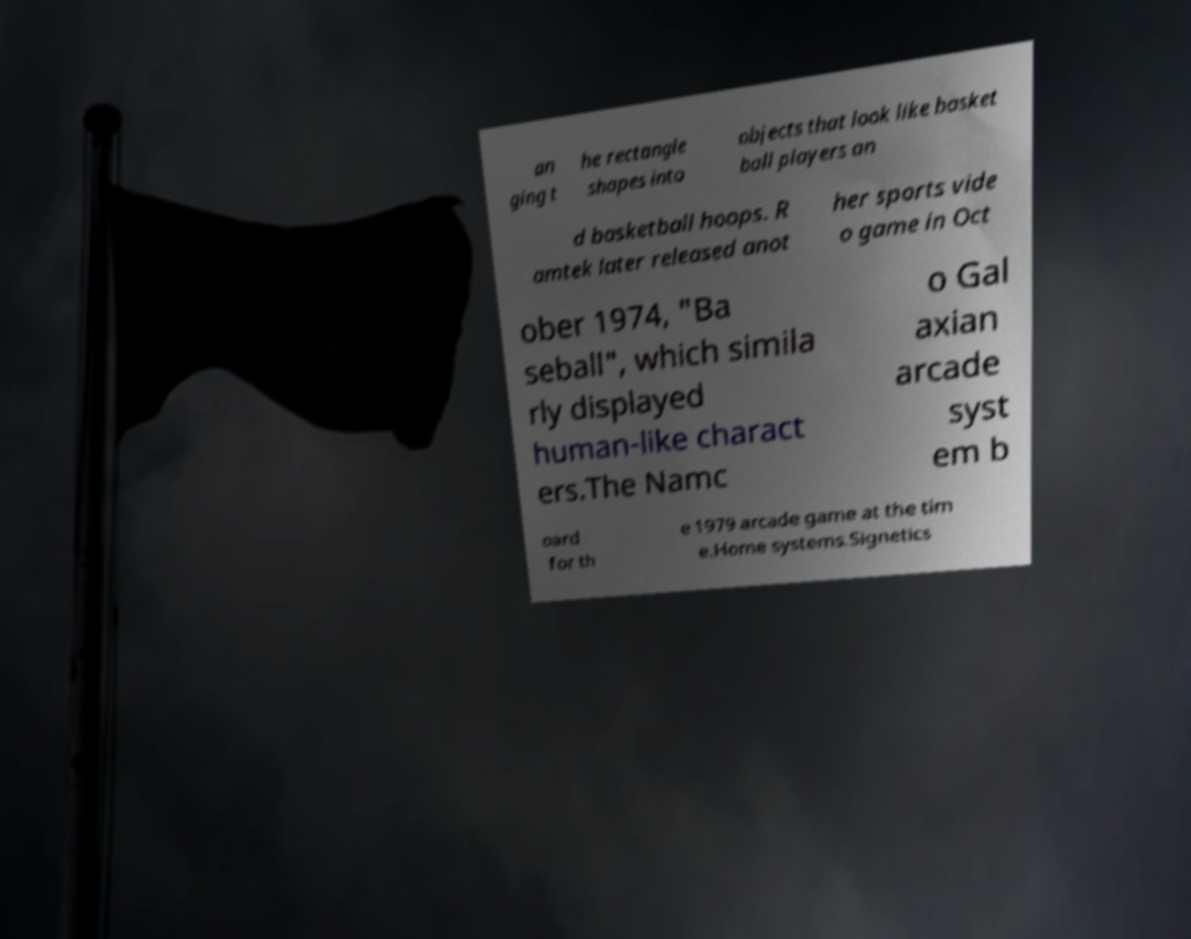Could you extract and type out the text from this image? an ging t he rectangle shapes into objects that look like basket ball players an d basketball hoops. R amtek later released anot her sports vide o game in Oct ober 1974, "Ba seball", which simila rly displayed human-like charact ers.The Namc o Gal axian arcade syst em b oard for th e 1979 arcade game at the tim e.Home systems.Signetics 